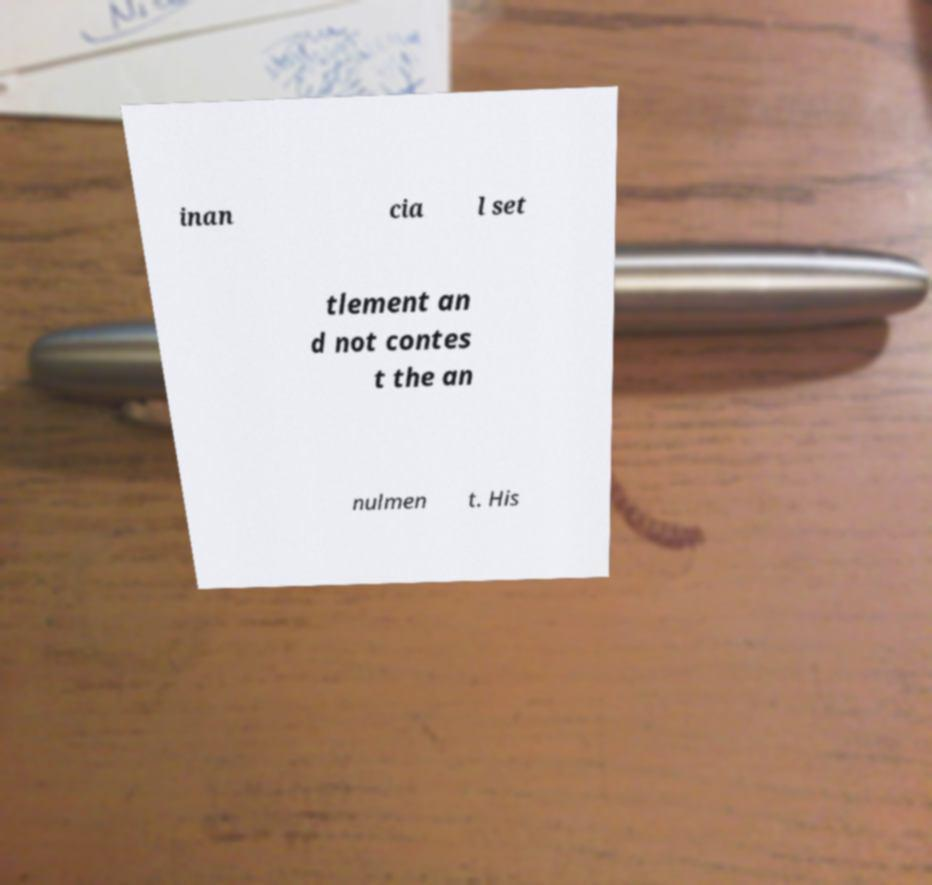I need the written content from this picture converted into text. Can you do that? inan cia l set tlement an d not contes t the an nulmen t. His 